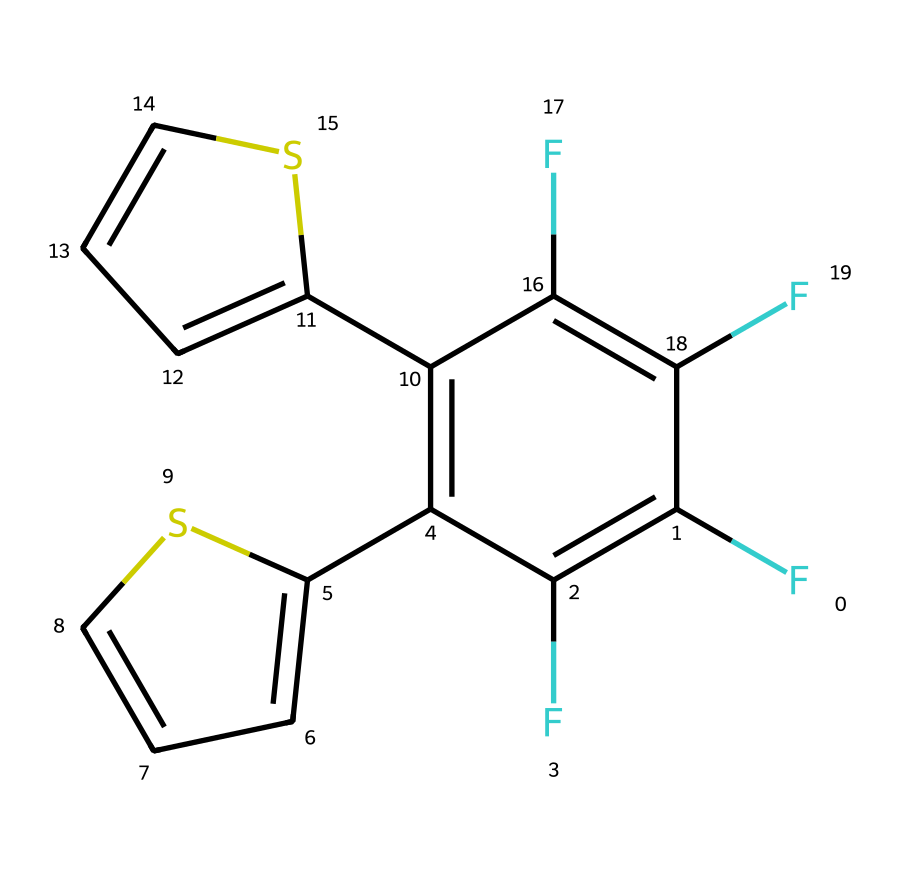What is the molecular formula of this compound? To determine the molecular formula, count the number of each type of atom in the provided SMILES. The structure contains 14 carbon (C) atoms, 8 hydrogen (H) atoms, and 4 fluorine (F) atoms. Thus, the molecular formula is C14H8F4.
Answer: C14H8F4 How many rings are present in the structure? Examine the SMILES representation. The structure contains two distinct rings formed by the carbon and sulfur atoms, specifically in the parts denoted by C=CS. Therefore, there are two rings present.
Answer: 2 What is the role of the sulfur atoms in the compound? In this molecular structure, the sulfur atoms (S) are typically involved in facilitating specific electronic properties and enhancing the photochromic behavior of the compound, allowing it to absorb light and respond to it. This is achieved through the significant interactions of sulfur with the adjacent carbon atoms.
Answer: photochromic behavior What functional groups are indicated in the compound? Analyze the structure to identify the functional groups present. The compound features alkenes (denoted by the double bonds) and CF (fluoro-substituted) groups. The presence of these functional groups contributes to the compound's unique reactivity and properties.
Answer: alkenes and fluorine groups What kind of structural isomerism might this compound exhibit? Based on the arrangement of atoms and bonds in this compound, it can exhibit geometric isomerism due to the presence of double bonds with restricted rotation. This leads to possible cis and trans forms concerning the positioning of substituents around those double bonds.
Answer: geometric isomerism 